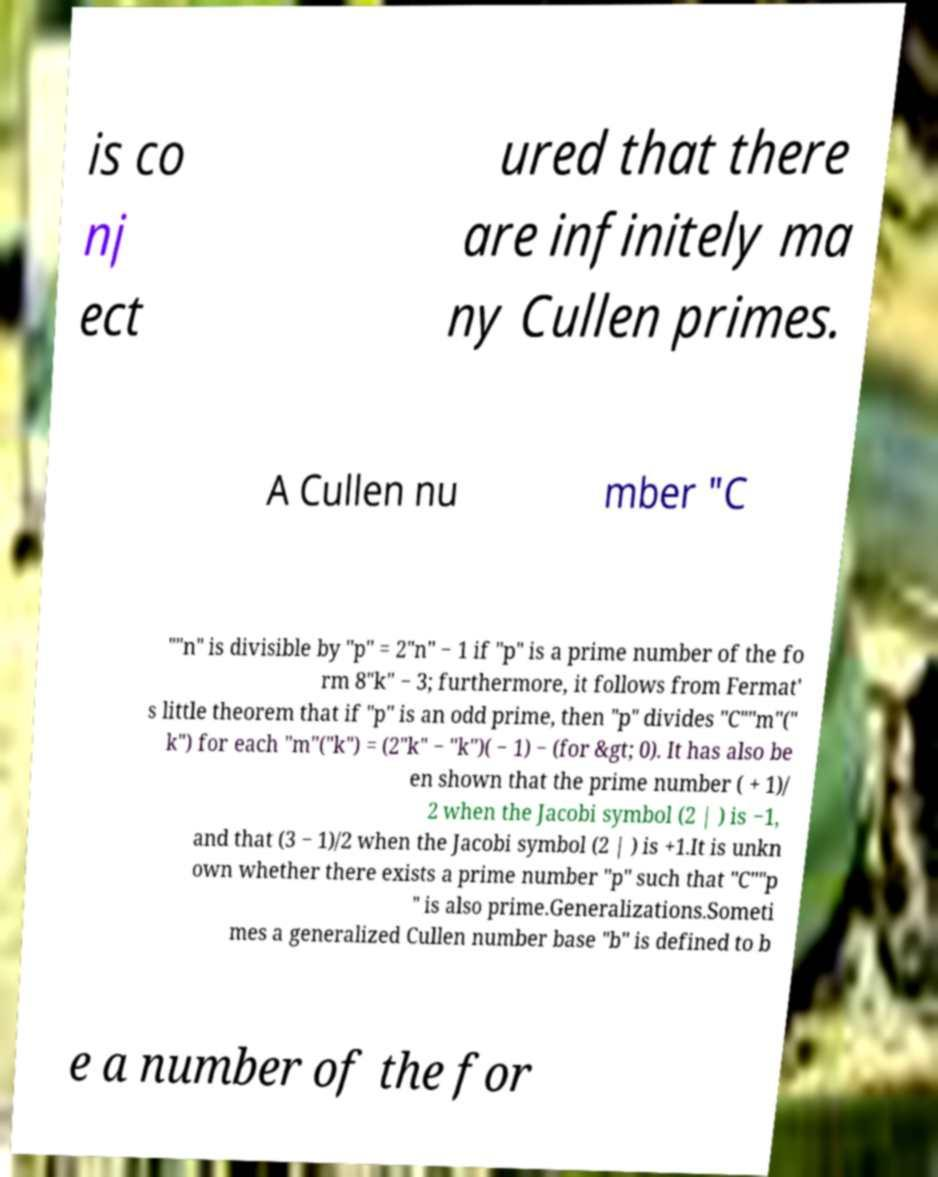Could you assist in decoding the text presented in this image and type it out clearly? is co nj ect ured that there are infinitely ma ny Cullen primes. A Cullen nu mber "C ""n" is divisible by "p" = 2"n" − 1 if "p" is a prime number of the fo rm 8"k" − 3; furthermore, it follows from Fermat' s little theorem that if "p" is an odd prime, then "p" divides "C""m"(" k") for each "m"("k") = (2"k" − "k")( − 1) − (for &gt; 0). It has also be en shown that the prime number ( + 1)/ 2 when the Jacobi symbol (2 | ) is −1, and that (3 − 1)/2 when the Jacobi symbol (2 | ) is +1.It is unkn own whether there exists a prime number "p" such that "C""p " is also prime.Generalizations.Someti mes a generalized Cullen number base "b" is defined to b e a number of the for 